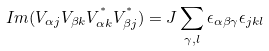<formula> <loc_0><loc_0><loc_500><loc_500>I m ( V _ { \alpha j } V _ { \beta k } V ^ { ^ { * } } _ { \alpha k } V ^ { ^ { * } } _ { \beta j } ) = J \sum _ { \gamma , l } \epsilon _ { \alpha \beta \gamma } \epsilon _ { j k l }</formula> 